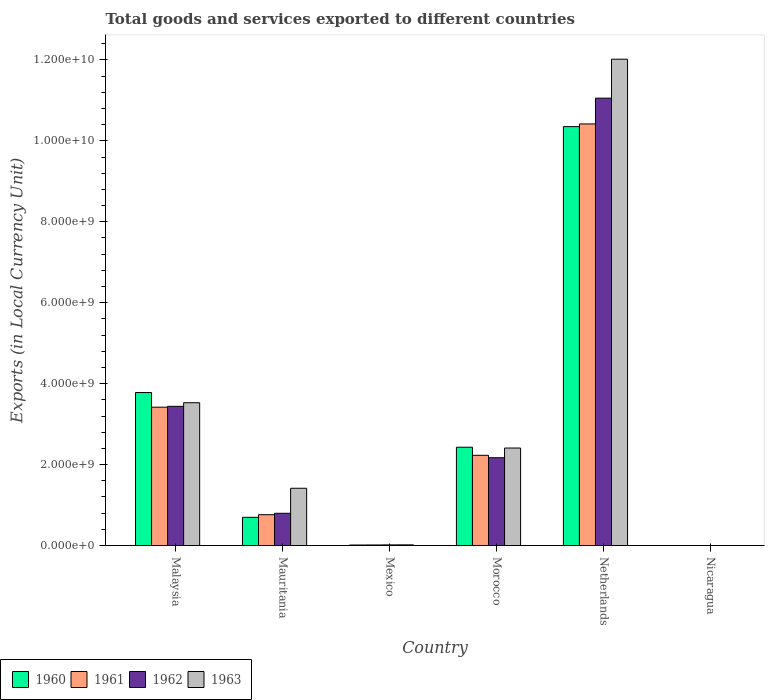How many groups of bars are there?
Offer a terse response. 6. Are the number of bars on each tick of the X-axis equal?
Your answer should be compact. Yes. How many bars are there on the 5th tick from the left?
Keep it short and to the point. 4. What is the label of the 4th group of bars from the left?
Make the answer very short. Morocco. In how many cases, is the number of bars for a given country not equal to the number of legend labels?
Your response must be concise. 0. What is the Amount of goods and services exports in 1962 in Malaysia?
Provide a short and direct response. 3.44e+09. Across all countries, what is the maximum Amount of goods and services exports in 1961?
Give a very brief answer. 1.04e+1. Across all countries, what is the minimum Amount of goods and services exports in 1962?
Your response must be concise. 0.15. In which country was the Amount of goods and services exports in 1962 minimum?
Keep it short and to the point. Nicaragua. What is the total Amount of goods and services exports in 1962 in the graph?
Your response must be concise. 1.75e+1. What is the difference between the Amount of goods and services exports in 1960 in Mexico and that in Netherlands?
Provide a succinct answer. -1.03e+1. What is the difference between the Amount of goods and services exports in 1962 in Netherlands and the Amount of goods and services exports in 1960 in Mauritania?
Offer a very short reply. 1.04e+1. What is the average Amount of goods and services exports in 1962 per country?
Your answer should be compact. 2.91e+09. What is the difference between the Amount of goods and services exports of/in 1962 and Amount of goods and services exports of/in 1961 in Morocco?
Offer a terse response. -6.00e+07. What is the ratio of the Amount of goods and services exports in 1962 in Malaysia to that in Mexico?
Your answer should be very brief. 211.27. Is the Amount of goods and services exports in 1961 in Malaysia less than that in Nicaragua?
Ensure brevity in your answer.  No. What is the difference between the highest and the second highest Amount of goods and services exports in 1961?
Offer a terse response. 8.19e+09. What is the difference between the highest and the lowest Amount of goods and services exports in 1961?
Your answer should be very brief. 1.04e+1. In how many countries, is the Amount of goods and services exports in 1960 greater than the average Amount of goods and services exports in 1960 taken over all countries?
Provide a short and direct response. 2. Is the sum of the Amount of goods and services exports in 1962 in Mexico and Netherlands greater than the maximum Amount of goods and services exports in 1963 across all countries?
Make the answer very short. No. Is it the case that in every country, the sum of the Amount of goods and services exports in 1962 and Amount of goods and services exports in 1963 is greater than the sum of Amount of goods and services exports in 1961 and Amount of goods and services exports in 1960?
Your answer should be very brief. No. What does the 3rd bar from the left in Nicaragua represents?
Provide a short and direct response. 1962. What does the 2nd bar from the right in Malaysia represents?
Provide a short and direct response. 1962. How many bars are there?
Offer a very short reply. 24. Are all the bars in the graph horizontal?
Your answer should be compact. No. Does the graph contain grids?
Give a very brief answer. No. How many legend labels are there?
Your answer should be very brief. 4. How are the legend labels stacked?
Provide a succinct answer. Horizontal. What is the title of the graph?
Ensure brevity in your answer.  Total goods and services exported to different countries. Does "1995" appear as one of the legend labels in the graph?
Your response must be concise. No. What is the label or title of the X-axis?
Provide a succinct answer. Country. What is the label or title of the Y-axis?
Your answer should be compact. Exports (in Local Currency Unit). What is the Exports (in Local Currency Unit) in 1960 in Malaysia?
Your answer should be very brief. 3.78e+09. What is the Exports (in Local Currency Unit) of 1961 in Malaysia?
Offer a very short reply. 3.42e+09. What is the Exports (in Local Currency Unit) of 1962 in Malaysia?
Make the answer very short. 3.44e+09. What is the Exports (in Local Currency Unit) of 1963 in Malaysia?
Keep it short and to the point. 3.53e+09. What is the Exports (in Local Currency Unit) in 1960 in Mauritania?
Give a very brief answer. 6.98e+08. What is the Exports (in Local Currency Unit) in 1961 in Mauritania?
Provide a succinct answer. 7.63e+08. What is the Exports (in Local Currency Unit) of 1962 in Mauritania?
Offer a very short reply. 7.98e+08. What is the Exports (in Local Currency Unit) of 1963 in Mauritania?
Your answer should be compact. 1.42e+09. What is the Exports (in Local Currency Unit) in 1960 in Mexico?
Provide a succinct answer. 1.39e+07. What is the Exports (in Local Currency Unit) in 1961 in Mexico?
Your response must be concise. 1.49e+07. What is the Exports (in Local Currency Unit) in 1962 in Mexico?
Provide a succinct answer. 1.63e+07. What is the Exports (in Local Currency Unit) in 1963 in Mexico?
Give a very brief answer. 1.76e+07. What is the Exports (in Local Currency Unit) of 1960 in Morocco?
Your answer should be compact. 2.43e+09. What is the Exports (in Local Currency Unit) of 1961 in Morocco?
Make the answer very short. 2.23e+09. What is the Exports (in Local Currency Unit) of 1962 in Morocco?
Keep it short and to the point. 2.17e+09. What is the Exports (in Local Currency Unit) of 1963 in Morocco?
Keep it short and to the point. 2.41e+09. What is the Exports (in Local Currency Unit) of 1960 in Netherlands?
Keep it short and to the point. 1.04e+1. What is the Exports (in Local Currency Unit) of 1961 in Netherlands?
Offer a very short reply. 1.04e+1. What is the Exports (in Local Currency Unit) in 1962 in Netherlands?
Your answer should be compact. 1.11e+1. What is the Exports (in Local Currency Unit) of 1963 in Netherlands?
Offer a terse response. 1.20e+1. What is the Exports (in Local Currency Unit) in 1960 in Nicaragua?
Your response must be concise. 0.11. What is the Exports (in Local Currency Unit) of 1961 in Nicaragua?
Your answer should be compact. 0.12. What is the Exports (in Local Currency Unit) in 1962 in Nicaragua?
Offer a very short reply. 0.15. What is the Exports (in Local Currency Unit) of 1963 in Nicaragua?
Ensure brevity in your answer.  0.18. Across all countries, what is the maximum Exports (in Local Currency Unit) of 1960?
Keep it short and to the point. 1.04e+1. Across all countries, what is the maximum Exports (in Local Currency Unit) in 1961?
Provide a short and direct response. 1.04e+1. Across all countries, what is the maximum Exports (in Local Currency Unit) of 1962?
Offer a terse response. 1.11e+1. Across all countries, what is the maximum Exports (in Local Currency Unit) in 1963?
Keep it short and to the point. 1.20e+1. Across all countries, what is the minimum Exports (in Local Currency Unit) of 1960?
Keep it short and to the point. 0.11. Across all countries, what is the minimum Exports (in Local Currency Unit) of 1961?
Keep it short and to the point. 0.12. Across all countries, what is the minimum Exports (in Local Currency Unit) in 1962?
Your answer should be very brief. 0.15. Across all countries, what is the minimum Exports (in Local Currency Unit) in 1963?
Give a very brief answer. 0.18. What is the total Exports (in Local Currency Unit) in 1960 in the graph?
Provide a succinct answer. 1.73e+1. What is the total Exports (in Local Currency Unit) in 1961 in the graph?
Make the answer very short. 1.68e+1. What is the total Exports (in Local Currency Unit) in 1962 in the graph?
Give a very brief answer. 1.75e+1. What is the total Exports (in Local Currency Unit) in 1963 in the graph?
Provide a succinct answer. 1.94e+1. What is the difference between the Exports (in Local Currency Unit) of 1960 in Malaysia and that in Mauritania?
Keep it short and to the point. 3.08e+09. What is the difference between the Exports (in Local Currency Unit) of 1961 in Malaysia and that in Mauritania?
Provide a short and direct response. 2.66e+09. What is the difference between the Exports (in Local Currency Unit) in 1962 in Malaysia and that in Mauritania?
Keep it short and to the point. 2.64e+09. What is the difference between the Exports (in Local Currency Unit) in 1963 in Malaysia and that in Mauritania?
Ensure brevity in your answer.  2.11e+09. What is the difference between the Exports (in Local Currency Unit) of 1960 in Malaysia and that in Mexico?
Give a very brief answer. 3.77e+09. What is the difference between the Exports (in Local Currency Unit) in 1961 in Malaysia and that in Mexico?
Keep it short and to the point. 3.40e+09. What is the difference between the Exports (in Local Currency Unit) of 1962 in Malaysia and that in Mexico?
Your answer should be compact. 3.42e+09. What is the difference between the Exports (in Local Currency Unit) in 1963 in Malaysia and that in Mexico?
Offer a very short reply. 3.51e+09. What is the difference between the Exports (in Local Currency Unit) of 1960 in Malaysia and that in Morocco?
Ensure brevity in your answer.  1.35e+09. What is the difference between the Exports (in Local Currency Unit) of 1961 in Malaysia and that in Morocco?
Provide a succinct answer. 1.19e+09. What is the difference between the Exports (in Local Currency Unit) of 1962 in Malaysia and that in Morocco?
Your answer should be compact. 1.27e+09. What is the difference between the Exports (in Local Currency Unit) in 1963 in Malaysia and that in Morocco?
Offer a terse response. 1.12e+09. What is the difference between the Exports (in Local Currency Unit) of 1960 in Malaysia and that in Netherlands?
Provide a short and direct response. -6.57e+09. What is the difference between the Exports (in Local Currency Unit) of 1961 in Malaysia and that in Netherlands?
Make the answer very short. -7.00e+09. What is the difference between the Exports (in Local Currency Unit) in 1962 in Malaysia and that in Netherlands?
Offer a very short reply. -7.61e+09. What is the difference between the Exports (in Local Currency Unit) of 1963 in Malaysia and that in Netherlands?
Offer a very short reply. -8.49e+09. What is the difference between the Exports (in Local Currency Unit) of 1960 in Malaysia and that in Nicaragua?
Ensure brevity in your answer.  3.78e+09. What is the difference between the Exports (in Local Currency Unit) in 1961 in Malaysia and that in Nicaragua?
Your answer should be very brief. 3.42e+09. What is the difference between the Exports (in Local Currency Unit) of 1962 in Malaysia and that in Nicaragua?
Keep it short and to the point. 3.44e+09. What is the difference between the Exports (in Local Currency Unit) in 1963 in Malaysia and that in Nicaragua?
Offer a terse response. 3.53e+09. What is the difference between the Exports (in Local Currency Unit) in 1960 in Mauritania and that in Mexico?
Your answer should be compact. 6.84e+08. What is the difference between the Exports (in Local Currency Unit) of 1961 in Mauritania and that in Mexico?
Make the answer very short. 7.48e+08. What is the difference between the Exports (in Local Currency Unit) in 1962 in Mauritania and that in Mexico?
Provide a short and direct response. 7.81e+08. What is the difference between the Exports (in Local Currency Unit) of 1963 in Mauritania and that in Mexico?
Your response must be concise. 1.40e+09. What is the difference between the Exports (in Local Currency Unit) of 1960 in Mauritania and that in Morocco?
Your response must be concise. -1.73e+09. What is the difference between the Exports (in Local Currency Unit) in 1961 in Mauritania and that in Morocco?
Offer a very short reply. -1.47e+09. What is the difference between the Exports (in Local Currency Unit) of 1962 in Mauritania and that in Morocco?
Your answer should be very brief. -1.37e+09. What is the difference between the Exports (in Local Currency Unit) of 1963 in Mauritania and that in Morocco?
Give a very brief answer. -9.94e+08. What is the difference between the Exports (in Local Currency Unit) in 1960 in Mauritania and that in Netherlands?
Your answer should be compact. -9.65e+09. What is the difference between the Exports (in Local Currency Unit) in 1961 in Mauritania and that in Netherlands?
Offer a terse response. -9.65e+09. What is the difference between the Exports (in Local Currency Unit) of 1962 in Mauritania and that in Netherlands?
Offer a very short reply. -1.03e+1. What is the difference between the Exports (in Local Currency Unit) of 1963 in Mauritania and that in Netherlands?
Ensure brevity in your answer.  -1.06e+1. What is the difference between the Exports (in Local Currency Unit) in 1960 in Mauritania and that in Nicaragua?
Offer a terse response. 6.98e+08. What is the difference between the Exports (in Local Currency Unit) in 1961 in Mauritania and that in Nicaragua?
Offer a very short reply. 7.63e+08. What is the difference between the Exports (in Local Currency Unit) of 1962 in Mauritania and that in Nicaragua?
Make the answer very short. 7.98e+08. What is the difference between the Exports (in Local Currency Unit) in 1963 in Mauritania and that in Nicaragua?
Give a very brief answer. 1.42e+09. What is the difference between the Exports (in Local Currency Unit) in 1960 in Mexico and that in Morocco?
Your answer should be very brief. -2.42e+09. What is the difference between the Exports (in Local Currency Unit) in 1961 in Mexico and that in Morocco?
Offer a terse response. -2.22e+09. What is the difference between the Exports (in Local Currency Unit) in 1962 in Mexico and that in Morocco?
Ensure brevity in your answer.  -2.15e+09. What is the difference between the Exports (in Local Currency Unit) of 1963 in Mexico and that in Morocco?
Offer a terse response. -2.39e+09. What is the difference between the Exports (in Local Currency Unit) of 1960 in Mexico and that in Netherlands?
Your answer should be compact. -1.03e+1. What is the difference between the Exports (in Local Currency Unit) of 1961 in Mexico and that in Netherlands?
Keep it short and to the point. -1.04e+1. What is the difference between the Exports (in Local Currency Unit) in 1962 in Mexico and that in Netherlands?
Your answer should be very brief. -1.10e+1. What is the difference between the Exports (in Local Currency Unit) in 1963 in Mexico and that in Netherlands?
Make the answer very short. -1.20e+1. What is the difference between the Exports (in Local Currency Unit) of 1960 in Mexico and that in Nicaragua?
Keep it short and to the point. 1.39e+07. What is the difference between the Exports (in Local Currency Unit) in 1961 in Mexico and that in Nicaragua?
Your answer should be very brief. 1.49e+07. What is the difference between the Exports (in Local Currency Unit) in 1962 in Mexico and that in Nicaragua?
Offer a terse response. 1.63e+07. What is the difference between the Exports (in Local Currency Unit) in 1963 in Mexico and that in Nicaragua?
Give a very brief answer. 1.76e+07. What is the difference between the Exports (in Local Currency Unit) in 1960 in Morocco and that in Netherlands?
Your answer should be very brief. -7.92e+09. What is the difference between the Exports (in Local Currency Unit) of 1961 in Morocco and that in Netherlands?
Ensure brevity in your answer.  -8.19e+09. What is the difference between the Exports (in Local Currency Unit) in 1962 in Morocco and that in Netherlands?
Your response must be concise. -8.88e+09. What is the difference between the Exports (in Local Currency Unit) in 1963 in Morocco and that in Netherlands?
Provide a succinct answer. -9.61e+09. What is the difference between the Exports (in Local Currency Unit) of 1960 in Morocco and that in Nicaragua?
Provide a succinct answer. 2.43e+09. What is the difference between the Exports (in Local Currency Unit) of 1961 in Morocco and that in Nicaragua?
Give a very brief answer. 2.23e+09. What is the difference between the Exports (in Local Currency Unit) in 1962 in Morocco and that in Nicaragua?
Your response must be concise. 2.17e+09. What is the difference between the Exports (in Local Currency Unit) in 1963 in Morocco and that in Nicaragua?
Provide a succinct answer. 2.41e+09. What is the difference between the Exports (in Local Currency Unit) in 1960 in Netherlands and that in Nicaragua?
Provide a short and direct response. 1.04e+1. What is the difference between the Exports (in Local Currency Unit) of 1961 in Netherlands and that in Nicaragua?
Your answer should be compact. 1.04e+1. What is the difference between the Exports (in Local Currency Unit) of 1962 in Netherlands and that in Nicaragua?
Ensure brevity in your answer.  1.11e+1. What is the difference between the Exports (in Local Currency Unit) of 1963 in Netherlands and that in Nicaragua?
Make the answer very short. 1.20e+1. What is the difference between the Exports (in Local Currency Unit) of 1960 in Malaysia and the Exports (in Local Currency Unit) of 1961 in Mauritania?
Provide a short and direct response. 3.02e+09. What is the difference between the Exports (in Local Currency Unit) of 1960 in Malaysia and the Exports (in Local Currency Unit) of 1962 in Mauritania?
Offer a terse response. 2.98e+09. What is the difference between the Exports (in Local Currency Unit) in 1960 in Malaysia and the Exports (in Local Currency Unit) in 1963 in Mauritania?
Make the answer very short. 2.37e+09. What is the difference between the Exports (in Local Currency Unit) of 1961 in Malaysia and the Exports (in Local Currency Unit) of 1962 in Mauritania?
Provide a succinct answer. 2.62e+09. What is the difference between the Exports (in Local Currency Unit) of 1961 in Malaysia and the Exports (in Local Currency Unit) of 1963 in Mauritania?
Offer a very short reply. 2.00e+09. What is the difference between the Exports (in Local Currency Unit) in 1962 in Malaysia and the Exports (in Local Currency Unit) in 1963 in Mauritania?
Ensure brevity in your answer.  2.02e+09. What is the difference between the Exports (in Local Currency Unit) in 1960 in Malaysia and the Exports (in Local Currency Unit) in 1961 in Mexico?
Provide a short and direct response. 3.77e+09. What is the difference between the Exports (in Local Currency Unit) of 1960 in Malaysia and the Exports (in Local Currency Unit) of 1962 in Mexico?
Offer a terse response. 3.76e+09. What is the difference between the Exports (in Local Currency Unit) in 1960 in Malaysia and the Exports (in Local Currency Unit) in 1963 in Mexico?
Keep it short and to the point. 3.76e+09. What is the difference between the Exports (in Local Currency Unit) in 1961 in Malaysia and the Exports (in Local Currency Unit) in 1962 in Mexico?
Your answer should be compact. 3.40e+09. What is the difference between the Exports (in Local Currency Unit) in 1961 in Malaysia and the Exports (in Local Currency Unit) in 1963 in Mexico?
Keep it short and to the point. 3.40e+09. What is the difference between the Exports (in Local Currency Unit) of 1962 in Malaysia and the Exports (in Local Currency Unit) of 1963 in Mexico?
Your answer should be very brief. 3.42e+09. What is the difference between the Exports (in Local Currency Unit) in 1960 in Malaysia and the Exports (in Local Currency Unit) in 1961 in Morocco?
Offer a very short reply. 1.55e+09. What is the difference between the Exports (in Local Currency Unit) of 1960 in Malaysia and the Exports (in Local Currency Unit) of 1962 in Morocco?
Your response must be concise. 1.61e+09. What is the difference between the Exports (in Local Currency Unit) of 1960 in Malaysia and the Exports (in Local Currency Unit) of 1963 in Morocco?
Provide a succinct answer. 1.37e+09. What is the difference between the Exports (in Local Currency Unit) of 1961 in Malaysia and the Exports (in Local Currency Unit) of 1962 in Morocco?
Ensure brevity in your answer.  1.25e+09. What is the difference between the Exports (in Local Currency Unit) of 1961 in Malaysia and the Exports (in Local Currency Unit) of 1963 in Morocco?
Provide a succinct answer. 1.01e+09. What is the difference between the Exports (in Local Currency Unit) in 1962 in Malaysia and the Exports (in Local Currency Unit) in 1963 in Morocco?
Keep it short and to the point. 1.03e+09. What is the difference between the Exports (in Local Currency Unit) of 1960 in Malaysia and the Exports (in Local Currency Unit) of 1961 in Netherlands?
Keep it short and to the point. -6.64e+09. What is the difference between the Exports (in Local Currency Unit) of 1960 in Malaysia and the Exports (in Local Currency Unit) of 1962 in Netherlands?
Provide a succinct answer. -7.27e+09. What is the difference between the Exports (in Local Currency Unit) of 1960 in Malaysia and the Exports (in Local Currency Unit) of 1963 in Netherlands?
Offer a terse response. -8.24e+09. What is the difference between the Exports (in Local Currency Unit) in 1961 in Malaysia and the Exports (in Local Currency Unit) in 1962 in Netherlands?
Make the answer very short. -7.64e+09. What is the difference between the Exports (in Local Currency Unit) of 1961 in Malaysia and the Exports (in Local Currency Unit) of 1963 in Netherlands?
Ensure brevity in your answer.  -8.60e+09. What is the difference between the Exports (in Local Currency Unit) in 1962 in Malaysia and the Exports (in Local Currency Unit) in 1963 in Netherlands?
Your answer should be very brief. -8.58e+09. What is the difference between the Exports (in Local Currency Unit) in 1960 in Malaysia and the Exports (in Local Currency Unit) in 1961 in Nicaragua?
Ensure brevity in your answer.  3.78e+09. What is the difference between the Exports (in Local Currency Unit) in 1960 in Malaysia and the Exports (in Local Currency Unit) in 1962 in Nicaragua?
Offer a very short reply. 3.78e+09. What is the difference between the Exports (in Local Currency Unit) of 1960 in Malaysia and the Exports (in Local Currency Unit) of 1963 in Nicaragua?
Provide a short and direct response. 3.78e+09. What is the difference between the Exports (in Local Currency Unit) of 1961 in Malaysia and the Exports (in Local Currency Unit) of 1962 in Nicaragua?
Provide a short and direct response. 3.42e+09. What is the difference between the Exports (in Local Currency Unit) in 1961 in Malaysia and the Exports (in Local Currency Unit) in 1963 in Nicaragua?
Your response must be concise. 3.42e+09. What is the difference between the Exports (in Local Currency Unit) of 1962 in Malaysia and the Exports (in Local Currency Unit) of 1963 in Nicaragua?
Ensure brevity in your answer.  3.44e+09. What is the difference between the Exports (in Local Currency Unit) of 1960 in Mauritania and the Exports (in Local Currency Unit) of 1961 in Mexico?
Offer a terse response. 6.83e+08. What is the difference between the Exports (in Local Currency Unit) of 1960 in Mauritania and the Exports (in Local Currency Unit) of 1962 in Mexico?
Offer a very short reply. 6.82e+08. What is the difference between the Exports (in Local Currency Unit) of 1960 in Mauritania and the Exports (in Local Currency Unit) of 1963 in Mexico?
Your response must be concise. 6.80e+08. What is the difference between the Exports (in Local Currency Unit) in 1961 in Mauritania and the Exports (in Local Currency Unit) in 1962 in Mexico?
Your answer should be compact. 7.46e+08. What is the difference between the Exports (in Local Currency Unit) of 1961 in Mauritania and the Exports (in Local Currency Unit) of 1963 in Mexico?
Provide a short and direct response. 7.45e+08. What is the difference between the Exports (in Local Currency Unit) of 1962 in Mauritania and the Exports (in Local Currency Unit) of 1963 in Mexico?
Give a very brief answer. 7.80e+08. What is the difference between the Exports (in Local Currency Unit) in 1960 in Mauritania and the Exports (in Local Currency Unit) in 1961 in Morocco?
Your answer should be compact. -1.53e+09. What is the difference between the Exports (in Local Currency Unit) in 1960 in Mauritania and the Exports (in Local Currency Unit) in 1962 in Morocco?
Offer a very short reply. -1.47e+09. What is the difference between the Exports (in Local Currency Unit) in 1960 in Mauritania and the Exports (in Local Currency Unit) in 1963 in Morocco?
Give a very brief answer. -1.71e+09. What is the difference between the Exports (in Local Currency Unit) in 1961 in Mauritania and the Exports (in Local Currency Unit) in 1962 in Morocco?
Make the answer very short. -1.41e+09. What is the difference between the Exports (in Local Currency Unit) in 1961 in Mauritania and the Exports (in Local Currency Unit) in 1963 in Morocco?
Offer a very short reply. -1.65e+09. What is the difference between the Exports (in Local Currency Unit) in 1962 in Mauritania and the Exports (in Local Currency Unit) in 1963 in Morocco?
Provide a succinct answer. -1.61e+09. What is the difference between the Exports (in Local Currency Unit) of 1960 in Mauritania and the Exports (in Local Currency Unit) of 1961 in Netherlands?
Provide a succinct answer. -9.72e+09. What is the difference between the Exports (in Local Currency Unit) in 1960 in Mauritania and the Exports (in Local Currency Unit) in 1962 in Netherlands?
Offer a very short reply. -1.04e+1. What is the difference between the Exports (in Local Currency Unit) in 1960 in Mauritania and the Exports (in Local Currency Unit) in 1963 in Netherlands?
Give a very brief answer. -1.13e+1. What is the difference between the Exports (in Local Currency Unit) in 1961 in Mauritania and the Exports (in Local Currency Unit) in 1962 in Netherlands?
Offer a terse response. -1.03e+1. What is the difference between the Exports (in Local Currency Unit) of 1961 in Mauritania and the Exports (in Local Currency Unit) of 1963 in Netherlands?
Make the answer very short. -1.13e+1. What is the difference between the Exports (in Local Currency Unit) in 1962 in Mauritania and the Exports (in Local Currency Unit) in 1963 in Netherlands?
Offer a terse response. -1.12e+1. What is the difference between the Exports (in Local Currency Unit) of 1960 in Mauritania and the Exports (in Local Currency Unit) of 1961 in Nicaragua?
Your answer should be compact. 6.98e+08. What is the difference between the Exports (in Local Currency Unit) in 1960 in Mauritania and the Exports (in Local Currency Unit) in 1962 in Nicaragua?
Keep it short and to the point. 6.98e+08. What is the difference between the Exports (in Local Currency Unit) of 1960 in Mauritania and the Exports (in Local Currency Unit) of 1963 in Nicaragua?
Make the answer very short. 6.98e+08. What is the difference between the Exports (in Local Currency Unit) in 1961 in Mauritania and the Exports (in Local Currency Unit) in 1962 in Nicaragua?
Your response must be concise. 7.63e+08. What is the difference between the Exports (in Local Currency Unit) in 1961 in Mauritania and the Exports (in Local Currency Unit) in 1963 in Nicaragua?
Provide a succinct answer. 7.63e+08. What is the difference between the Exports (in Local Currency Unit) of 1962 in Mauritania and the Exports (in Local Currency Unit) of 1963 in Nicaragua?
Provide a short and direct response. 7.98e+08. What is the difference between the Exports (in Local Currency Unit) in 1960 in Mexico and the Exports (in Local Currency Unit) in 1961 in Morocco?
Ensure brevity in your answer.  -2.22e+09. What is the difference between the Exports (in Local Currency Unit) of 1960 in Mexico and the Exports (in Local Currency Unit) of 1962 in Morocco?
Provide a short and direct response. -2.16e+09. What is the difference between the Exports (in Local Currency Unit) of 1960 in Mexico and the Exports (in Local Currency Unit) of 1963 in Morocco?
Ensure brevity in your answer.  -2.40e+09. What is the difference between the Exports (in Local Currency Unit) in 1961 in Mexico and the Exports (in Local Currency Unit) in 1962 in Morocco?
Your answer should be very brief. -2.16e+09. What is the difference between the Exports (in Local Currency Unit) in 1961 in Mexico and the Exports (in Local Currency Unit) in 1963 in Morocco?
Keep it short and to the point. -2.40e+09. What is the difference between the Exports (in Local Currency Unit) in 1962 in Mexico and the Exports (in Local Currency Unit) in 1963 in Morocco?
Give a very brief answer. -2.39e+09. What is the difference between the Exports (in Local Currency Unit) in 1960 in Mexico and the Exports (in Local Currency Unit) in 1961 in Netherlands?
Your response must be concise. -1.04e+1. What is the difference between the Exports (in Local Currency Unit) of 1960 in Mexico and the Exports (in Local Currency Unit) of 1962 in Netherlands?
Offer a terse response. -1.10e+1. What is the difference between the Exports (in Local Currency Unit) of 1960 in Mexico and the Exports (in Local Currency Unit) of 1963 in Netherlands?
Your response must be concise. -1.20e+1. What is the difference between the Exports (in Local Currency Unit) in 1961 in Mexico and the Exports (in Local Currency Unit) in 1962 in Netherlands?
Your response must be concise. -1.10e+1. What is the difference between the Exports (in Local Currency Unit) of 1961 in Mexico and the Exports (in Local Currency Unit) of 1963 in Netherlands?
Provide a succinct answer. -1.20e+1. What is the difference between the Exports (in Local Currency Unit) of 1962 in Mexico and the Exports (in Local Currency Unit) of 1963 in Netherlands?
Provide a short and direct response. -1.20e+1. What is the difference between the Exports (in Local Currency Unit) of 1960 in Mexico and the Exports (in Local Currency Unit) of 1961 in Nicaragua?
Keep it short and to the point. 1.39e+07. What is the difference between the Exports (in Local Currency Unit) of 1960 in Mexico and the Exports (in Local Currency Unit) of 1962 in Nicaragua?
Your answer should be compact. 1.39e+07. What is the difference between the Exports (in Local Currency Unit) of 1960 in Mexico and the Exports (in Local Currency Unit) of 1963 in Nicaragua?
Give a very brief answer. 1.39e+07. What is the difference between the Exports (in Local Currency Unit) of 1961 in Mexico and the Exports (in Local Currency Unit) of 1962 in Nicaragua?
Your answer should be compact. 1.49e+07. What is the difference between the Exports (in Local Currency Unit) in 1961 in Mexico and the Exports (in Local Currency Unit) in 1963 in Nicaragua?
Give a very brief answer. 1.49e+07. What is the difference between the Exports (in Local Currency Unit) of 1962 in Mexico and the Exports (in Local Currency Unit) of 1963 in Nicaragua?
Offer a very short reply. 1.63e+07. What is the difference between the Exports (in Local Currency Unit) of 1960 in Morocco and the Exports (in Local Currency Unit) of 1961 in Netherlands?
Offer a very short reply. -7.99e+09. What is the difference between the Exports (in Local Currency Unit) in 1960 in Morocco and the Exports (in Local Currency Unit) in 1962 in Netherlands?
Keep it short and to the point. -8.62e+09. What is the difference between the Exports (in Local Currency Unit) of 1960 in Morocco and the Exports (in Local Currency Unit) of 1963 in Netherlands?
Keep it short and to the point. -9.59e+09. What is the difference between the Exports (in Local Currency Unit) of 1961 in Morocco and the Exports (in Local Currency Unit) of 1962 in Netherlands?
Ensure brevity in your answer.  -8.82e+09. What is the difference between the Exports (in Local Currency Unit) of 1961 in Morocco and the Exports (in Local Currency Unit) of 1963 in Netherlands?
Make the answer very short. -9.79e+09. What is the difference between the Exports (in Local Currency Unit) in 1962 in Morocco and the Exports (in Local Currency Unit) in 1963 in Netherlands?
Give a very brief answer. -9.85e+09. What is the difference between the Exports (in Local Currency Unit) in 1960 in Morocco and the Exports (in Local Currency Unit) in 1961 in Nicaragua?
Make the answer very short. 2.43e+09. What is the difference between the Exports (in Local Currency Unit) in 1960 in Morocco and the Exports (in Local Currency Unit) in 1962 in Nicaragua?
Your answer should be very brief. 2.43e+09. What is the difference between the Exports (in Local Currency Unit) in 1960 in Morocco and the Exports (in Local Currency Unit) in 1963 in Nicaragua?
Offer a very short reply. 2.43e+09. What is the difference between the Exports (in Local Currency Unit) in 1961 in Morocco and the Exports (in Local Currency Unit) in 1962 in Nicaragua?
Your answer should be very brief. 2.23e+09. What is the difference between the Exports (in Local Currency Unit) in 1961 in Morocco and the Exports (in Local Currency Unit) in 1963 in Nicaragua?
Keep it short and to the point. 2.23e+09. What is the difference between the Exports (in Local Currency Unit) of 1962 in Morocco and the Exports (in Local Currency Unit) of 1963 in Nicaragua?
Make the answer very short. 2.17e+09. What is the difference between the Exports (in Local Currency Unit) of 1960 in Netherlands and the Exports (in Local Currency Unit) of 1961 in Nicaragua?
Offer a very short reply. 1.04e+1. What is the difference between the Exports (in Local Currency Unit) in 1960 in Netherlands and the Exports (in Local Currency Unit) in 1962 in Nicaragua?
Offer a very short reply. 1.04e+1. What is the difference between the Exports (in Local Currency Unit) of 1960 in Netherlands and the Exports (in Local Currency Unit) of 1963 in Nicaragua?
Your answer should be very brief. 1.04e+1. What is the difference between the Exports (in Local Currency Unit) of 1961 in Netherlands and the Exports (in Local Currency Unit) of 1962 in Nicaragua?
Ensure brevity in your answer.  1.04e+1. What is the difference between the Exports (in Local Currency Unit) in 1961 in Netherlands and the Exports (in Local Currency Unit) in 1963 in Nicaragua?
Offer a terse response. 1.04e+1. What is the difference between the Exports (in Local Currency Unit) of 1962 in Netherlands and the Exports (in Local Currency Unit) of 1963 in Nicaragua?
Provide a succinct answer. 1.11e+1. What is the average Exports (in Local Currency Unit) in 1960 per country?
Make the answer very short. 2.88e+09. What is the average Exports (in Local Currency Unit) of 1961 per country?
Offer a very short reply. 2.81e+09. What is the average Exports (in Local Currency Unit) of 1962 per country?
Your response must be concise. 2.91e+09. What is the average Exports (in Local Currency Unit) in 1963 per country?
Give a very brief answer. 3.23e+09. What is the difference between the Exports (in Local Currency Unit) in 1960 and Exports (in Local Currency Unit) in 1961 in Malaysia?
Your answer should be very brief. 3.62e+08. What is the difference between the Exports (in Local Currency Unit) in 1960 and Exports (in Local Currency Unit) in 1962 in Malaysia?
Make the answer very short. 3.41e+08. What is the difference between the Exports (in Local Currency Unit) of 1960 and Exports (in Local Currency Unit) of 1963 in Malaysia?
Offer a terse response. 2.52e+08. What is the difference between the Exports (in Local Currency Unit) in 1961 and Exports (in Local Currency Unit) in 1962 in Malaysia?
Offer a terse response. -2.11e+07. What is the difference between the Exports (in Local Currency Unit) in 1961 and Exports (in Local Currency Unit) in 1963 in Malaysia?
Your answer should be compact. -1.10e+08. What is the difference between the Exports (in Local Currency Unit) in 1962 and Exports (in Local Currency Unit) in 1963 in Malaysia?
Provide a short and direct response. -8.93e+07. What is the difference between the Exports (in Local Currency Unit) in 1960 and Exports (in Local Currency Unit) in 1961 in Mauritania?
Provide a short and direct response. -6.48e+07. What is the difference between the Exports (in Local Currency Unit) of 1960 and Exports (in Local Currency Unit) of 1962 in Mauritania?
Provide a succinct answer. -9.97e+07. What is the difference between the Exports (in Local Currency Unit) in 1960 and Exports (in Local Currency Unit) in 1963 in Mauritania?
Offer a terse response. -7.18e+08. What is the difference between the Exports (in Local Currency Unit) in 1961 and Exports (in Local Currency Unit) in 1962 in Mauritania?
Your answer should be very brief. -3.49e+07. What is the difference between the Exports (in Local Currency Unit) in 1961 and Exports (in Local Currency Unit) in 1963 in Mauritania?
Keep it short and to the point. -6.53e+08. What is the difference between the Exports (in Local Currency Unit) in 1962 and Exports (in Local Currency Unit) in 1963 in Mauritania?
Provide a succinct answer. -6.18e+08. What is the difference between the Exports (in Local Currency Unit) in 1960 and Exports (in Local Currency Unit) in 1961 in Mexico?
Give a very brief answer. -1.03e+06. What is the difference between the Exports (in Local Currency Unit) in 1960 and Exports (in Local Currency Unit) in 1962 in Mexico?
Keep it short and to the point. -2.42e+06. What is the difference between the Exports (in Local Currency Unit) of 1960 and Exports (in Local Currency Unit) of 1963 in Mexico?
Your response must be concise. -3.77e+06. What is the difference between the Exports (in Local Currency Unit) of 1961 and Exports (in Local Currency Unit) of 1962 in Mexico?
Your answer should be very brief. -1.39e+06. What is the difference between the Exports (in Local Currency Unit) in 1961 and Exports (in Local Currency Unit) in 1963 in Mexico?
Keep it short and to the point. -2.75e+06. What is the difference between the Exports (in Local Currency Unit) in 1962 and Exports (in Local Currency Unit) in 1963 in Mexico?
Make the answer very short. -1.36e+06. What is the difference between the Exports (in Local Currency Unit) in 1960 and Exports (in Local Currency Unit) in 1962 in Morocco?
Offer a very short reply. 2.60e+08. What is the difference between the Exports (in Local Currency Unit) of 1960 and Exports (in Local Currency Unit) of 1963 in Morocco?
Keep it short and to the point. 2.00e+07. What is the difference between the Exports (in Local Currency Unit) in 1961 and Exports (in Local Currency Unit) in 1962 in Morocco?
Offer a very short reply. 6.00e+07. What is the difference between the Exports (in Local Currency Unit) in 1961 and Exports (in Local Currency Unit) in 1963 in Morocco?
Ensure brevity in your answer.  -1.80e+08. What is the difference between the Exports (in Local Currency Unit) of 1962 and Exports (in Local Currency Unit) of 1963 in Morocco?
Give a very brief answer. -2.40e+08. What is the difference between the Exports (in Local Currency Unit) in 1960 and Exports (in Local Currency Unit) in 1961 in Netherlands?
Your response must be concise. -6.60e+07. What is the difference between the Exports (in Local Currency Unit) in 1960 and Exports (in Local Currency Unit) in 1962 in Netherlands?
Keep it short and to the point. -7.03e+08. What is the difference between the Exports (in Local Currency Unit) in 1960 and Exports (in Local Currency Unit) in 1963 in Netherlands?
Your response must be concise. -1.67e+09. What is the difference between the Exports (in Local Currency Unit) of 1961 and Exports (in Local Currency Unit) of 1962 in Netherlands?
Offer a very short reply. -6.37e+08. What is the difference between the Exports (in Local Currency Unit) in 1961 and Exports (in Local Currency Unit) in 1963 in Netherlands?
Your answer should be very brief. -1.60e+09. What is the difference between the Exports (in Local Currency Unit) in 1962 and Exports (in Local Currency Unit) in 1963 in Netherlands?
Offer a very short reply. -9.62e+08. What is the difference between the Exports (in Local Currency Unit) of 1960 and Exports (in Local Currency Unit) of 1961 in Nicaragua?
Offer a very short reply. -0.01. What is the difference between the Exports (in Local Currency Unit) in 1960 and Exports (in Local Currency Unit) in 1962 in Nicaragua?
Your answer should be very brief. -0.04. What is the difference between the Exports (in Local Currency Unit) in 1960 and Exports (in Local Currency Unit) in 1963 in Nicaragua?
Your answer should be compact. -0.07. What is the difference between the Exports (in Local Currency Unit) of 1961 and Exports (in Local Currency Unit) of 1962 in Nicaragua?
Your answer should be very brief. -0.03. What is the difference between the Exports (in Local Currency Unit) in 1961 and Exports (in Local Currency Unit) in 1963 in Nicaragua?
Your answer should be very brief. -0.06. What is the difference between the Exports (in Local Currency Unit) of 1962 and Exports (in Local Currency Unit) of 1963 in Nicaragua?
Keep it short and to the point. -0.03. What is the ratio of the Exports (in Local Currency Unit) in 1960 in Malaysia to that in Mauritania?
Your response must be concise. 5.42. What is the ratio of the Exports (in Local Currency Unit) of 1961 in Malaysia to that in Mauritania?
Your response must be concise. 4.48. What is the ratio of the Exports (in Local Currency Unit) of 1962 in Malaysia to that in Mauritania?
Offer a terse response. 4.31. What is the ratio of the Exports (in Local Currency Unit) in 1963 in Malaysia to that in Mauritania?
Keep it short and to the point. 2.49. What is the ratio of the Exports (in Local Currency Unit) in 1960 in Malaysia to that in Mexico?
Offer a terse response. 272.71. What is the ratio of the Exports (in Local Currency Unit) of 1961 in Malaysia to that in Mexico?
Your answer should be compact. 229.6. What is the ratio of the Exports (in Local Currency Unit) of 1962 in Malaysia to that in Mexico?
Ensure brevity in your answer.  211.27. What is the ratio of the Exports (in Local Currency Unit) of 1963 in Malaysia to that in Mexico?
Your answer should be very brief. 200.08. What is the ratio of the Exports (in Local Currency Unit) in 1960 in Malaysia to that in Morocco?
Make the answer very short. 1.56. What is the ratio of the Exports (in Local Currency Unit) in 1961 in Malaysia to that in Morocco?
Offer a terse response. 1.53. What is the ratio of the Exports (in Local Currency Unit) of 1962 in Malaysia to that in Morocco?
Your answer should be very brief. 1.59. What is the ratio of the Exports (in Local Currency Unit) of 1963 in Malaysia to that in Morocco?
Offer a terse response. 1.46. What is the ratio of the Exports (in Local Currency Unit) in 1960 in Malaysia to that in Netherlands?
Your answer should be very brief. 0.37. What is the ratio of the Exports (in Local Currency Unit) in 1961 in Malaysia to that in Netherlands?
Ensure brevity in your answer.  0.33. What is the ratio of the Exports (in Local Currency Unit) in 1962 in Malaysia to that in Netherlands?
Your response must be concise. 0.31. What is the ratio of the Exports (in Local Currency Unit) of 1963 in Malaysia to that in Netherlands?
Your response must be concise. 0.29. What is the ratio of the Exports (in Local Currency Unit) of 1960 in Malaysia to that in Nicaragua?
Offer a terse response. 3.40e+1. What is the ratio of the Exports (in Local Currency Unit) in 1961 in Malaysia to that in Nicaragua?
Offer a terse response. 2.89e+1. What is the ratio of the Exports (in Local Currency Unit) of 1962 in Malaysia to that in Nicaragua?
Your response must be concise. 2.34e+1. What is the ratio of the Exports (in Local Currency Unit) of 1963 in Malaysia to that in Nicaragua?
Provide a succinct answer. 1.99e+1. What is the ratio of the Exports (in Local Currency Unit) in 1960 in Mauritania to that in Mexico?
Your answer should be compact. 50.34. What is the ratio of the Exports (in Local Currency Unit) in 1961 in Mauritania to that in Mexico?
Give a very brief answer. 51.22. What is the ratio of the Exports (in Local Currency Unit) in 1962 in Mauritania to that in Mexico?
Keep it short and to the point. 48.99. What is the ratio of the Exports (in Local Currency Unit) of 1963 in Mauritania to that in Mexico?
Ensure brevity in your answer.  80.26. What is the ratio of the Exports (in Local Currency Unit) of 1960 in Mauritania to that in Morocco?
Offer a very short reply. 0.29. What is the ratio of the Exports (in Local Currency Unit) of 1961 in Mauritania to that in Morocco?
Make the answer very short. 0.34. What is the ratio of the Exports (in Local Currency Unit) in 1962 in Mauritania to that in Morocco?
Keep it short and to the point. 0.37. What is the ratio of the Exports (in Local Currency Unit) of 1963 in Mauritania to that in Morocco?
Give a very brief answer. 0.59. What is the ratio of the Exports (in Local Currency Unit) of 1960 in Mauritania to that in Netherlands?
Make the answer very short. 0.07. What is the ratio of the Exports (in Local Currency Unit) in 1961 in Mauritania to that in Netherlands?
Your response must be concise. 0.07. What is the ratio of the Exports (in Local Currency Unit) in 1962 in Mauritania to that in Netherlands?
Your response must be concise. 0.07. What is the ratio of the Exports (in Local Currency Unit) of 1963 in Mauritania to that in Netherlands?
Keep it short and to the point. 0.12. What is the ratio of the Exports (in Local Currency Unit) of 1960 in Mauritania to that in Nicaragua?
Offer a terse response. 6.28e+09. What is the ratio of the Exports (in Local Currency Unit) in 1961 in Mauritania to that in Nicaragua?
Offer a terse response. 6.45e+09. What is the ratio of the Exports (in Local Currency Unit) in 1962 in Mauritania to that in Nicaragua?
Offer a very short reply. 5.42e+09. What is the ratio of the Exports (in Local Currency Unit) of 1963 in Mauritania to that in Nicaragua?
Provide a succinct answer. 7.98e+09. What is the ratio of the Exports (in Local Currency Unit) in 1960 in Mexico to that in Morocco?
Make the answer very short. 0.01. What is the ratio of the Exports (in Local Currency Unit) in 1961 in Mexico to that in Morocco?
Your answer should be compact. 0.01. What is the ratio of the Exports (in Local Currency Unit) in 1962 in Mexico to that in Morocco?
Offer a terse response. 0.01. What is the ratio of the Exports (in Local Currency Unit) of 1963 in Mexico to that in Morocco?
Your answer should be very brief. 0.01. What is the ratio of the Exports (in Local Currency Unit) of 1960 in Mexico to that in Netherlands?
Keep it short and to the point. 0. What is the ratio of the Exports (in Local Currency Unit) in 1961 in Mexico to that in Netherlands?
Offer a very short reply. 0. What is the ratio of the Exports (in Local Currency Unit) in 1962 in Mexico to that in Netherlands?
Make the answer very short. 0. What is the ratio of the Exports (in Local Currency Unit) of 1963 in Mexico to that in Netherlands?
Ensure brevity in your answer.  0. What is the ratio of the Exports (in Local Currency Unit) of 1960 in Mexico to that in Nicaragua?
Your answer should be compact. 1.25e+08. What is the ratio of the Exports (in Local Currency Unit) of 1961 in Mexico to that in Nicaragua?
Provide a short and direct response. 1.26e+08. What is the ratio of the Exports (in Local Currency Unit) in 1962 in Mexico to that in Nicaragua?
Give a very brief answer. 1.11e+08. What is the ratio of the Exports (in Local Currency Unit) of 1963 in Mexico to that in Nicaragua?
Provide a short and direct response. 9.95e+07. What is the ratio of the Exports (in Local Currency Unit) in 1960 in Morocco to that in Netherlands?
Your answer should be compact. 0.23. What is the ratio of the Exports (in Local Currency Unit) of 1961 in Morocco to that in Netherlands?
Ensure brevity in your answer.  0.21. What is the ratio of the Exports (in Local Currency Unit) in 1962 in Morocco to that in Netherlands?
Give a very brief answer. 0.2. What is the ratio of the Exports (in Local Currency Unit) of 1963 in Morocco to that in Netherlands?
Ensure brevity in your answer.  0.2. What is the ratio of the Exports (in Local Currency Unit) in 1960 in Morocco to that in Nicaragua?
Provide a succinct answer. 2.19e+1. What is the ratio of the Exports (in Local Currency Unit) of 1961 in Morocco to that in Nicaragua?
Give a very brief answer. 1.89e+1. What is the ratio of the Exports (in Local Currency Unit) in 1962 in Morocco to that in Nicaragua?
Your answer should be compact. 1.47e+1. What is the ratio of the Exports (in Local Currency Unit) of 1963 in Morocco to that in Nicaragua?
Your response must be concise. 1.36e+1. What is the ratio of the Exports (in Local Currency Unit) of 1960 in Netherlands to that in Nicaragua?
Your answer should be very brief. 9.31e+1. What is the ratio of the Exports (in Local Currency Unit) in 1961 in Netherlands to that in Nicaragua?
Offer a terse response. 8.81e+1. What is the ratio of the Exports (in Local Currency Unit) in 1962 in Netherlands to that in Nicaragua?
Ensure brevity in your answer.  7.51e+1. What is the ratio of the Exports (in Local Currency Unit) of 1963 in Netherlands to that in Nicaragua?
Ensure brevity in your answer.  6.78e+1. What is the difference between the highest and the second highest Exports (in Local Currency Unit) in 1960?
Offer a very short reply. 6.57e+09. What is the difference between the highest and the second highest Exports (in Local Currency Unit) in 1961?
Make the answer very short. 7.00e+09. What is the difference between the highest and the second highest Exports (in Local Currency Unit) of 1962?
Provide a short and direct response. 7.61e+09. What is the difference between the highest and the second highest Exports (in Local Currency Unit) of 1963?
Offer a terse response. 8.49e+09. What is the difference between the highest and the lowest Exports (in Local Currency Unit) in 1960?
Keep it short and to the point. 1.04e+1. What is the difference between the highest and the lowest Exports (in Local Currency Unit) of 1961?
Ensure brevity in your answer.  1.04e+1. What is the difference between the highest and the lowest Exports (in Local Currency Unit) of 1962?
Provide a succinct answer. 1.11e+1. What is the difference between the highest and the lowest Exports (in Local Currency Unit) in 1963?
Give a very brief answer. 1.20e+1. 